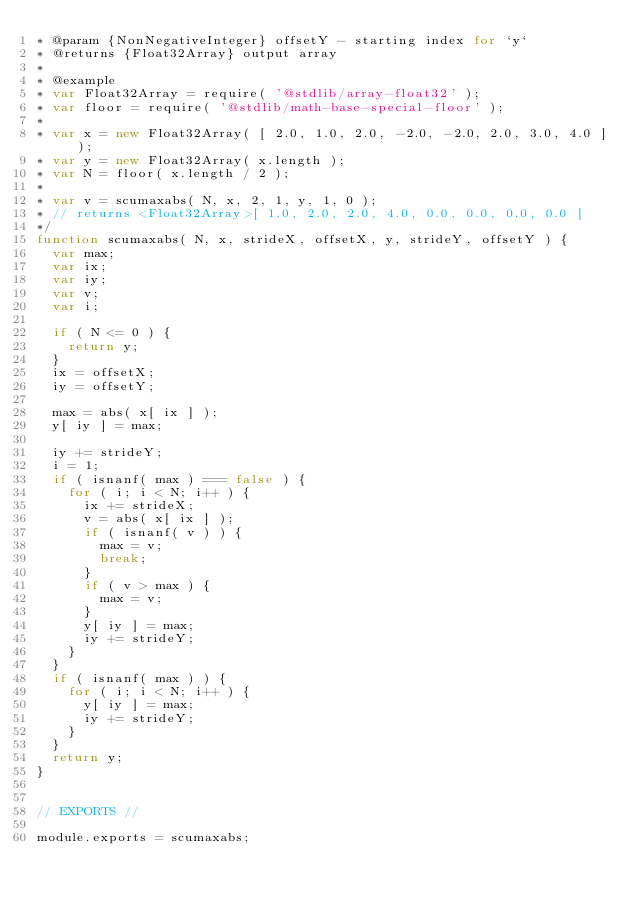<code> <loc_0><loc_0><loc_500><loc_500><_JavaScript_>* @param {NonNegativeInteger} offsetY - starting index for `y`
* @returns {Float32Array} output array
*
* @example
* var Float32Array = require( '@stdlib/array-float32' );
* var floor = require( '@stdlib/math-base-special-floor' );
*
* var x = new Float32Array( [ 2.0, 1.0, 2.0, -2.0, -2.0, 2.0, 3.0, 4.0 ] );
* var y = new Float32Array( x.length );
* var N = floor( x.length / 2 );
*
* var v = scumaxabs( N, x, 2, 1, y, 1, 0 );
* // returns <Float32Array>[ 1.0, 2.0, 2.0, 4.0, 0.0, 0.0, 0.0, 0.0 ]
*/
function scumaxabs( N, x, strideX, offsetX, y, strideY, offsetY ) {
	var max;
	var ix;
	var iy;
	var v;
	var i;

	if ( N <= 0 ) {
		return y;
	}
	ix = offsetX;
	iy = offsetY;

	max = abs( x[ ix ] );
	y[ iy ] = max;

	iy += strideY;
	i = 1;
	if ( isnanf( max ) === false ) {
		for ( i; i < N; i++ ) {
			ix += strideX;
			v = abs( x[ ix ] );
			if ( isnanf( v ) ) {
				max = v;
				break;
			}
			if ( v > max ) {
				max = v;
			}
			y[ iy ] = max;
			iy += strideY;
		}
	}
	if ( isnanf( max ) ) {
		for ( i; i < N; i++ ) {
			y[ iy ] = max;
			iy += strideY;
		}
	}
	return y;
}


// EXPORTS //

module.exports = scumaxabs;
</code> 